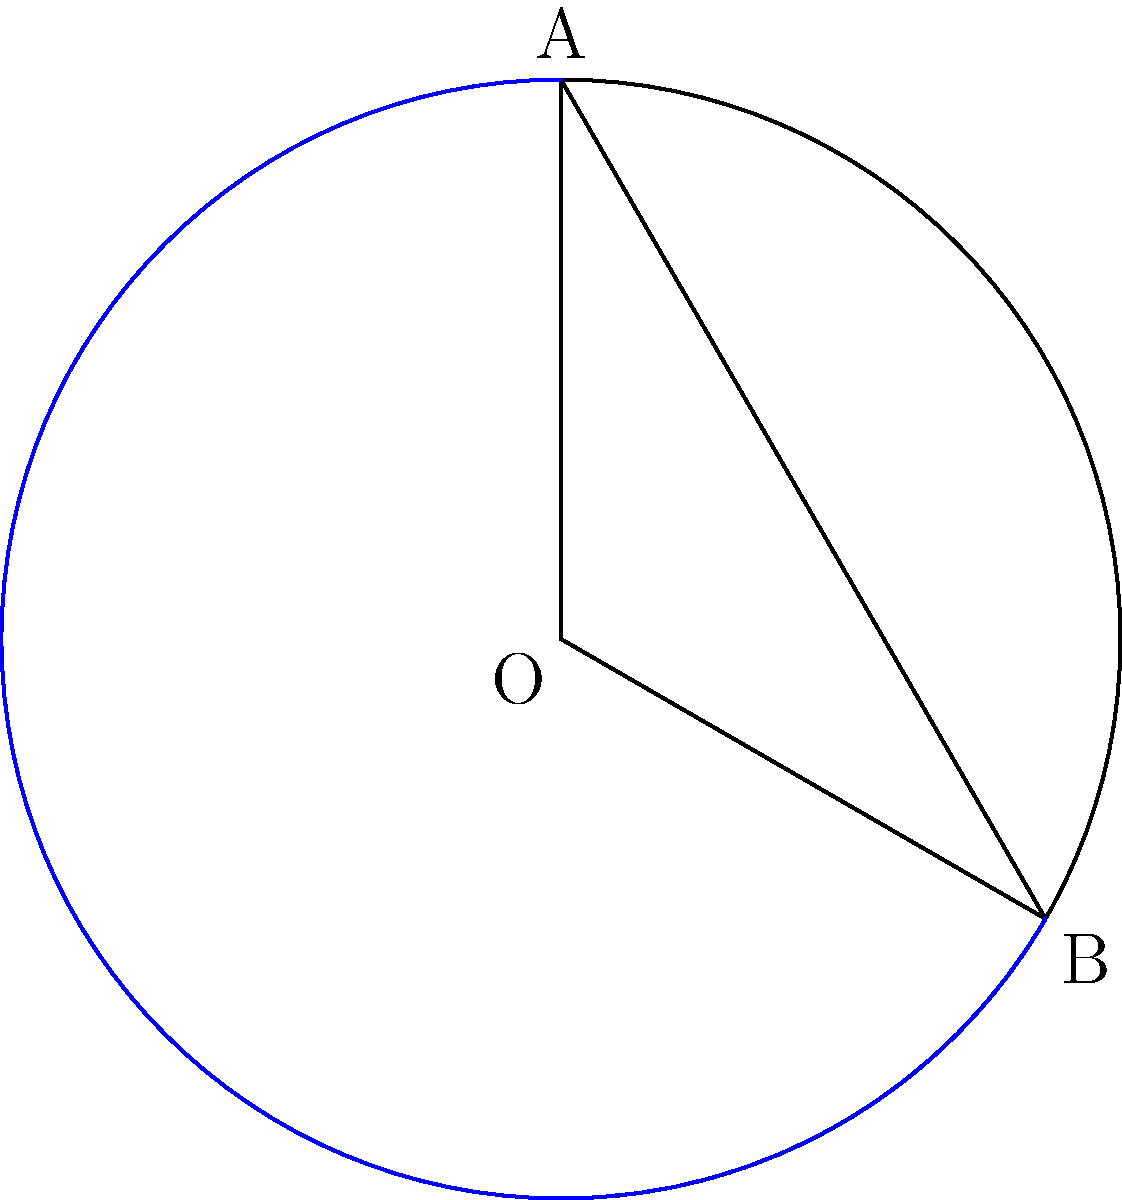In a circular collaboration tool interface, a sector is highlighted by a chord AB and an arc. Given that the radius of the circle is 10 units and the central angle subtended by the chord is 120°, calculate the area of the circular segment formed by the chord and the arc. How might this relate to user interface design in visual collaboration tools? To solve this problem, we'll follow these steps:

1) First, we need to calculate the area of the sector:
   Area of sector = $\frac{\theta}{360°} \pi r^2$, where $\theta$ is the central angle in degrees
   Area of sector = $\frac{120}{360} \pi (10)^2 = \frac{1}{3} \pi (100) = \frac{100\pi}{3}$ square units

2) Next, we calculate the area of the triangle OAB:
   Area of triangle = $\frac{1}{2} r^2 \sin \theta$
   Area of triangle = $\frac{1}{2} (10)^2 \sin 120° = 50 \cdot \frac{\sqrt{3}}{2} = 25\sqrt{3}$ square units

3) The area of the segment is the difference between the sector area and the triangle area:
   Area of segment = Area of sector - Area of triangle
   Area of segment = $\frac{100\pi}{3} - 25\sqrt{3}$ square units

This calculation is relevant to user interface design in visual collaboration tools as it can help determine the optimal size and shape of interactive elements or highlighted areas within a circular interface, ensuring efficient use of space while maintaining user-friendly proportions.
Answer: $\frac{100\pi}{3} - 25\sqrt{3}$ square units 